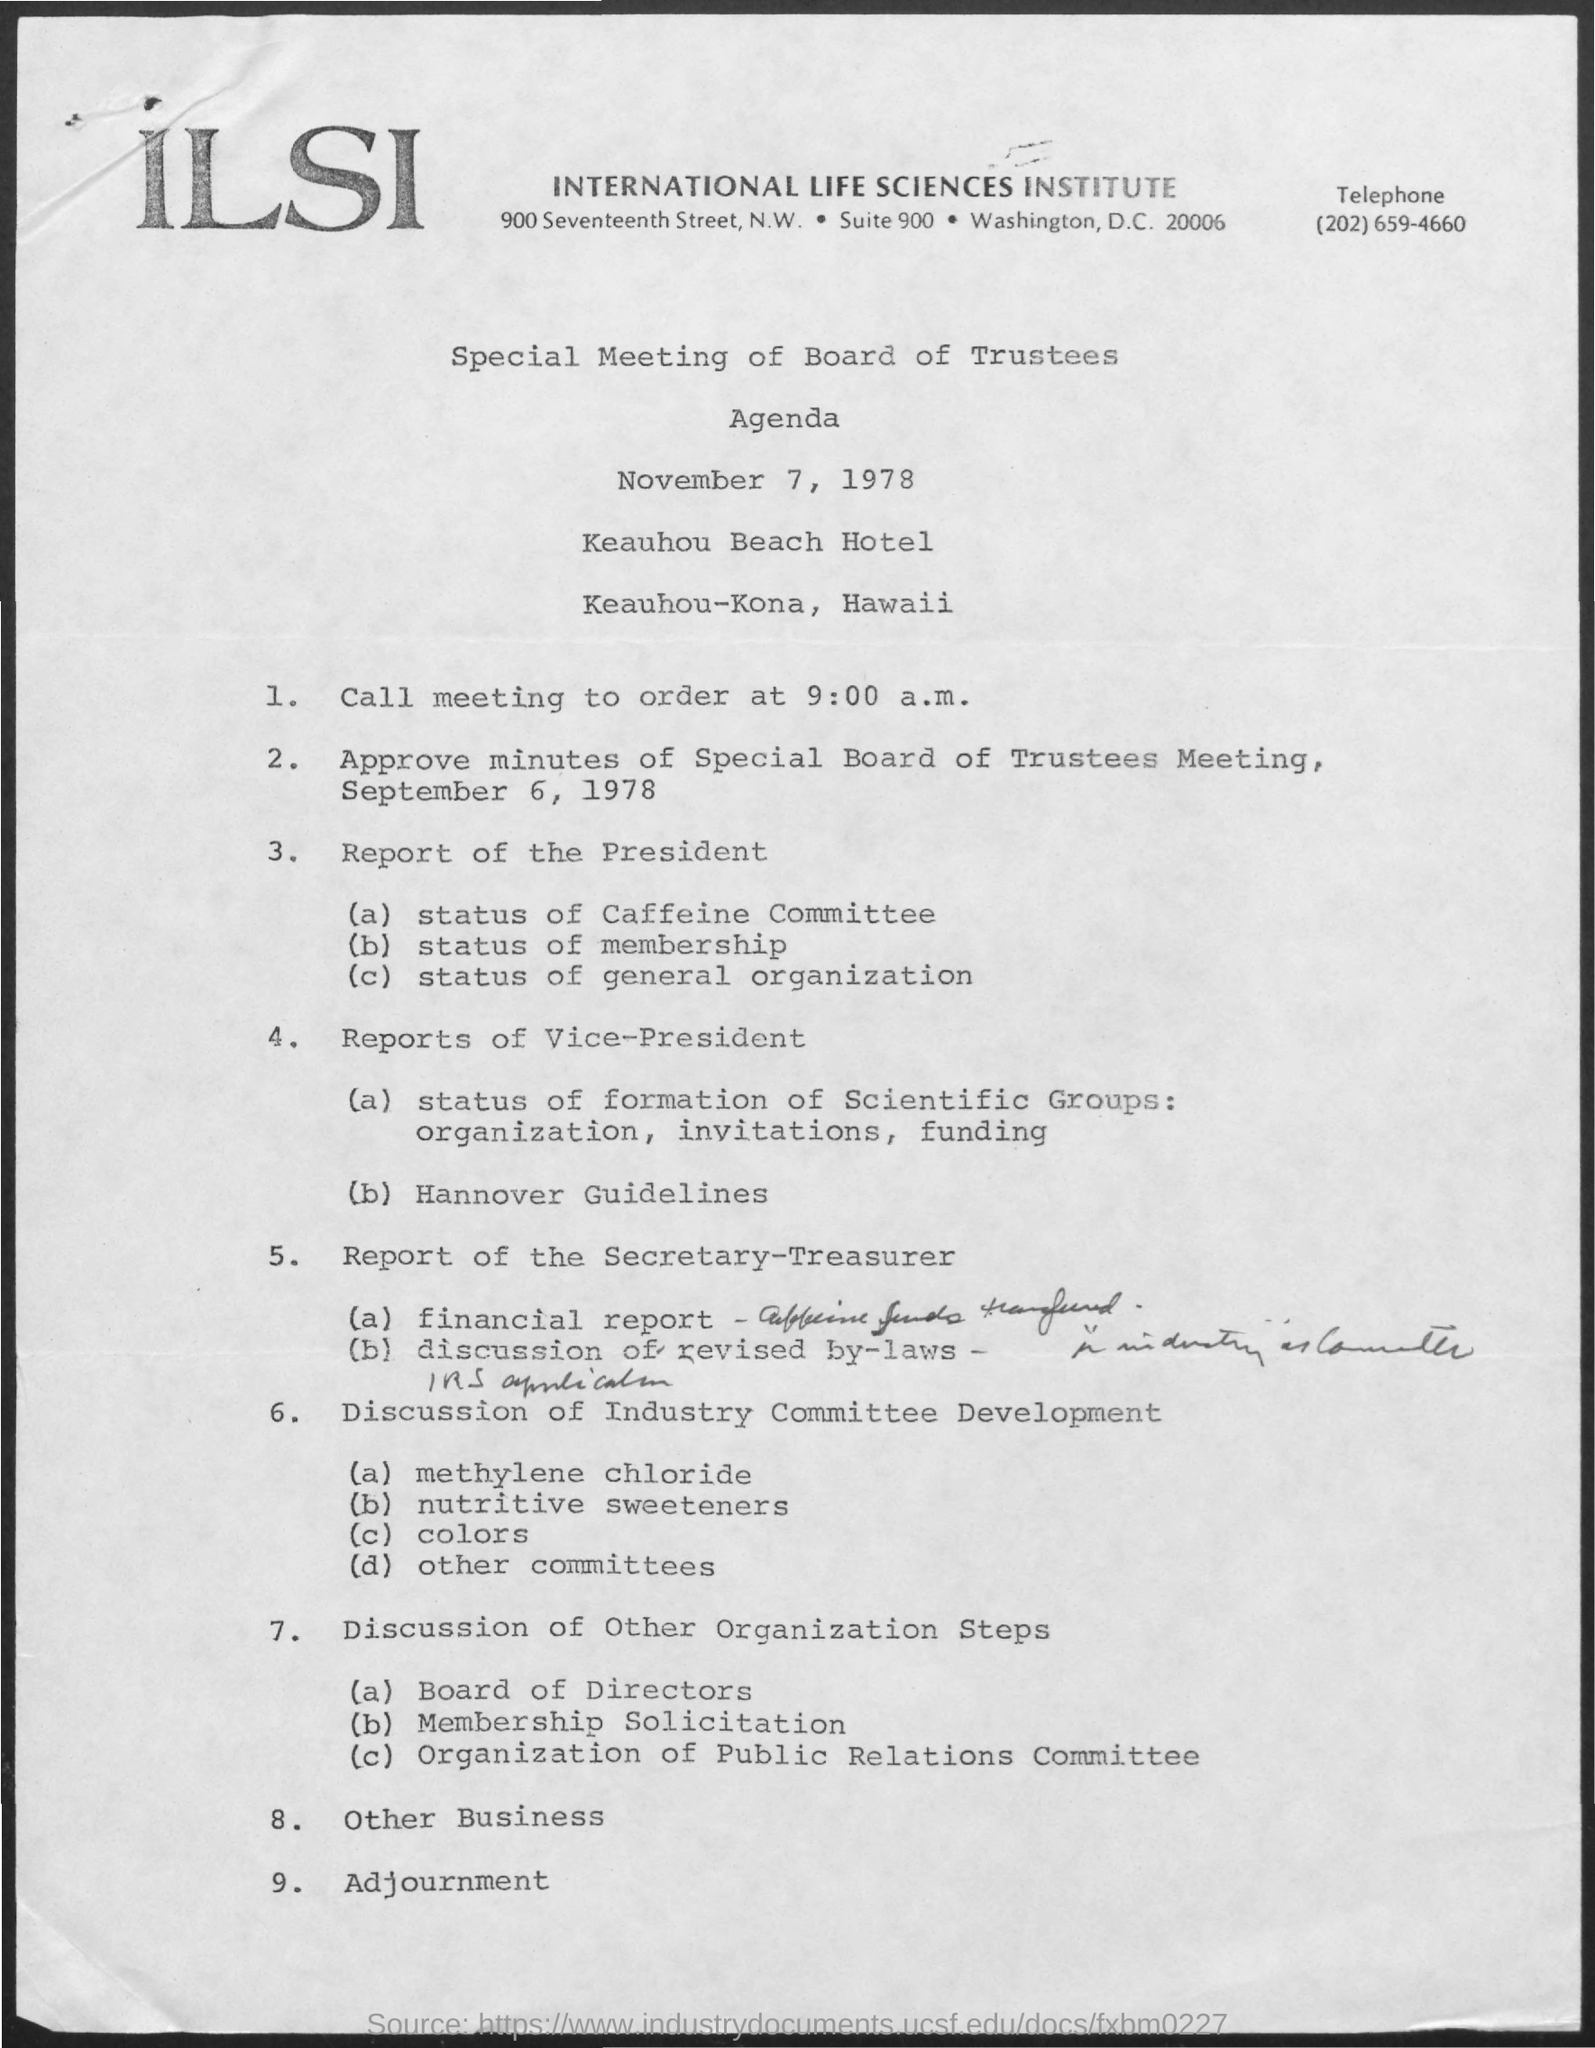Outline some significant characteristics in this image. There are currently 9 agendas in existence. The date of the Special Meeting of the Board Trustees was November 7, 1978. I have declared that the last agenda item is adjournment. 